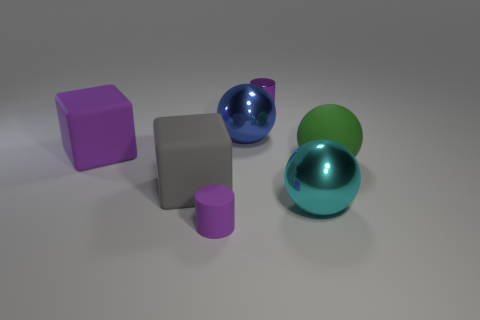How many purple objects are the same size as the blue metallic sphere?
Ensure brevity in your answer.  1. The green rubber ball has what size?
Provide a short and direct response. Large. There is a green object; what number of small purple metallic things are on the left side of it?
Offer a very short reply. 1. The big green object that is the same material as the gray object is what shape?
Provide a succinct answer. Sphere. Is the number of small purple cylinders that are to the right of the blue object less than the number of cylinders that are to the right of the green thing?
Make the answer very short. No. Are there more purple rubber cubes than small purple balls?
Your answer should be very brief. Yes. What is the large gray block made of?
Your answer should be very brief. Rubber. There is a rubber block in front of the green matte thing; what color is it?
Keep it short and to the point. Gray. Is the number of large matte objects to the left of the small rubber thing greater than the number of big metal balls that are on the right side of the large cyan metallic ball?
Provide a short and direct response. Yes. What size is the matte thing to the right of the metallic ball that is behind the shiny sphere that is in front of the large gray block?
Your response must be concise. Large. 